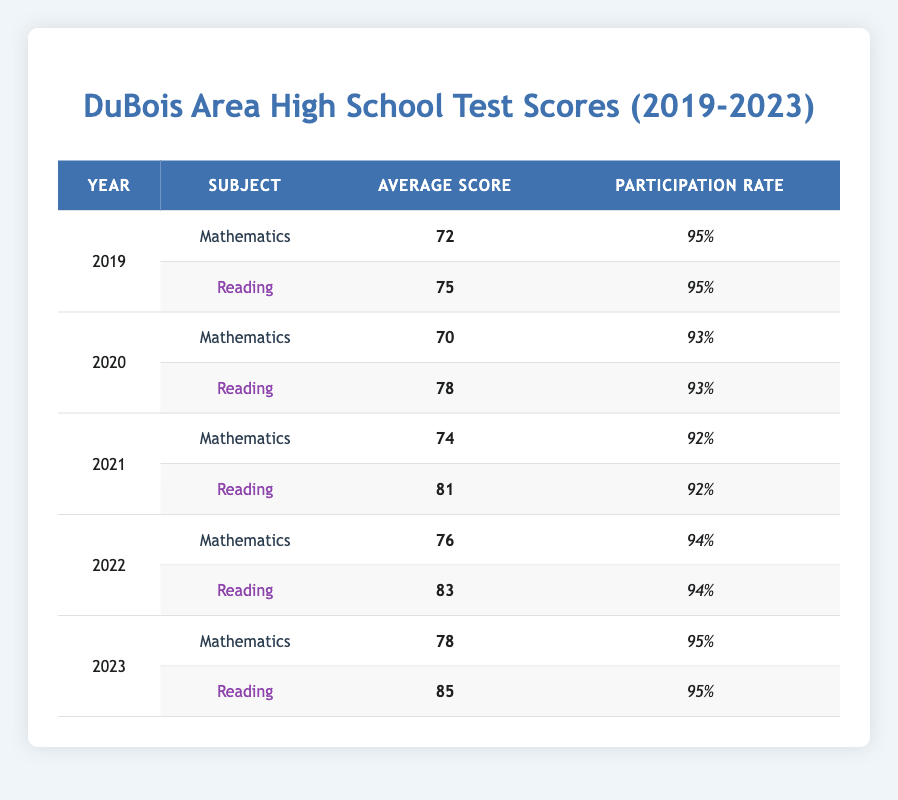What was the average score for Mathematics in 2022? The average score for Mathematics in 2022 is stated in the table as 76.
Answer: 76 What was the participation rate for Reading in 2020? The participation rate for Reading in 2020, as shown in the table, is 93%.
Answer: 93% Was the average score for Reading higher than the average score for Mathematics in 2021? In 2021, the average score for Reading is 81 and for Mathematics is 74. Since 81 is greater than 74, the answer is yes.
Answer: Yes What is the average participation rate for all subjects over the five years? The participation rates for all subjects from the years are: 95, 95, 93, 93, 92, 92, 94, 94, 95, 95. The sum is 935, and there are 10 values, so the average participation rate is 935 / 10 = 93.5%.
Answer: 93.5% In which year did DuBois Area High School achieve the highest average score for Reading? By comparing the average scores for Reading from each year, we see that the score in 2023 was the highest at 85.
Answer: 2023 Which subject had a higher average score in 2019? The scores for 2019 were Mathematics at 72 and Reading at 75. Since 75 is greater than 72, Reading had the higher score.
Answer: Reading What was the difference in average scores between Mathematics and Reading in 2022? The average score for Mathematics in 2022 is 76, while for Reading it is 83. The difference is 83 - 76 = 7.
Answer: 7 Did the average score for Mathematics increase from 2020 to 2023? The average score for Mathematics in 2020 is 70, while in 2023 it is 78. Since 78 is greater than 70, the average score did increase.
Answer: Yes What was the total average score for all subjects in 2021? To find the total average score for 2021, we add the average scores: Mathematics (74) + Reading (81) = 155. The average score is 155 / 2 = 77.5.
Answer: 77.5 